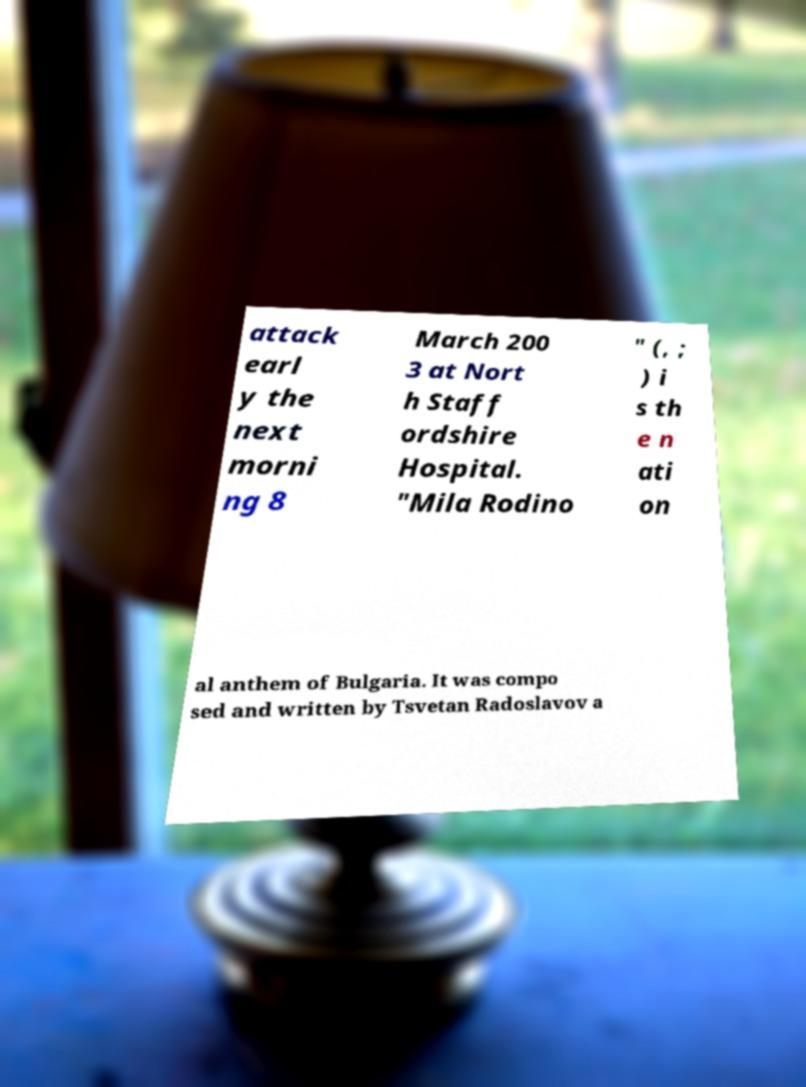Please identify and transcribe the text found in this image. attack earl y the next morni ng 8 March 200 3 at Nort h Staff ordshire Hospital. "Mila Rodino " (, ; ) i s th e n ati on al anthem of Bulgaria. It was compo sed and written by Tsvetan Radoslavov a 